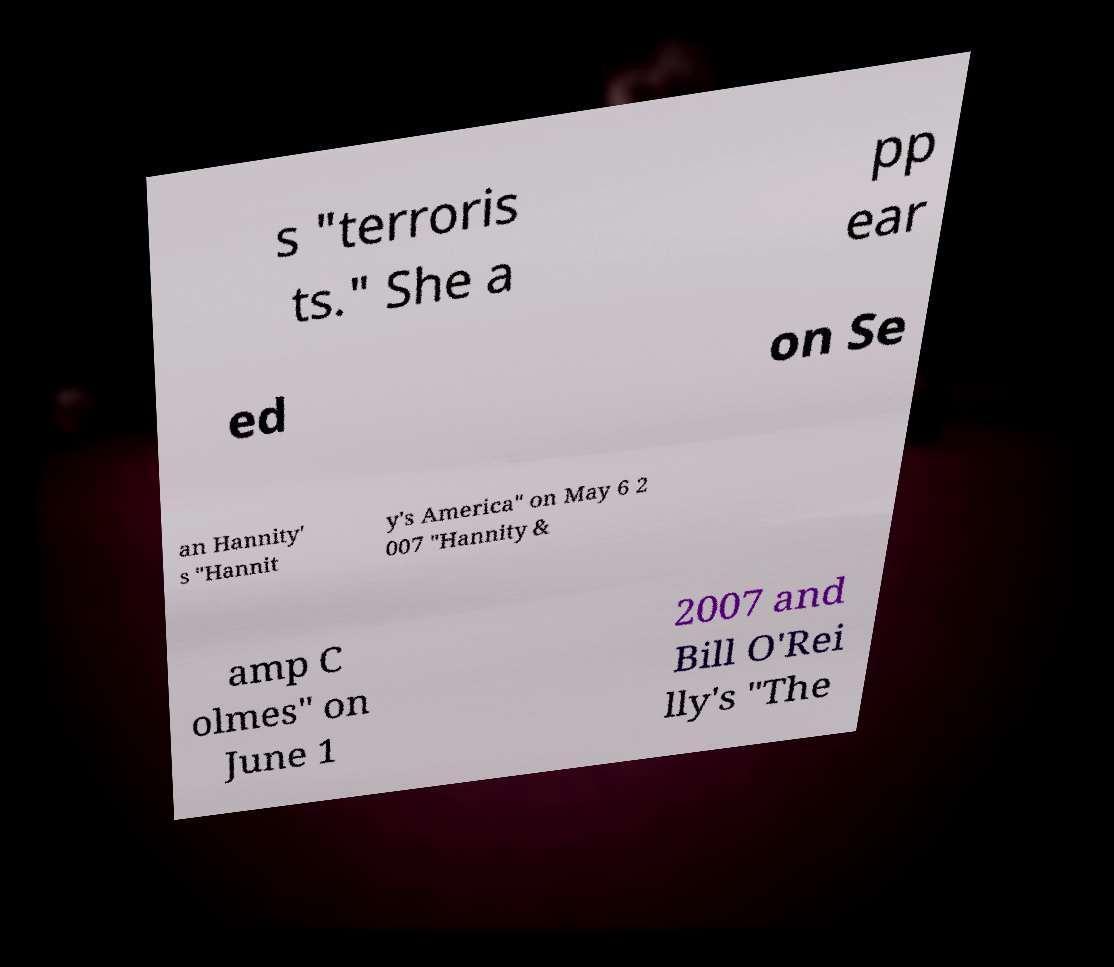Could you extract and type out the text from this image? s "terroris ts." She a pp ear ed on Se an Hannity' s "Hannit y's America" on May 6 2 007 "Hannity & amp C olmes" on June 1 2007 and Bill O'Rei lly's "The 